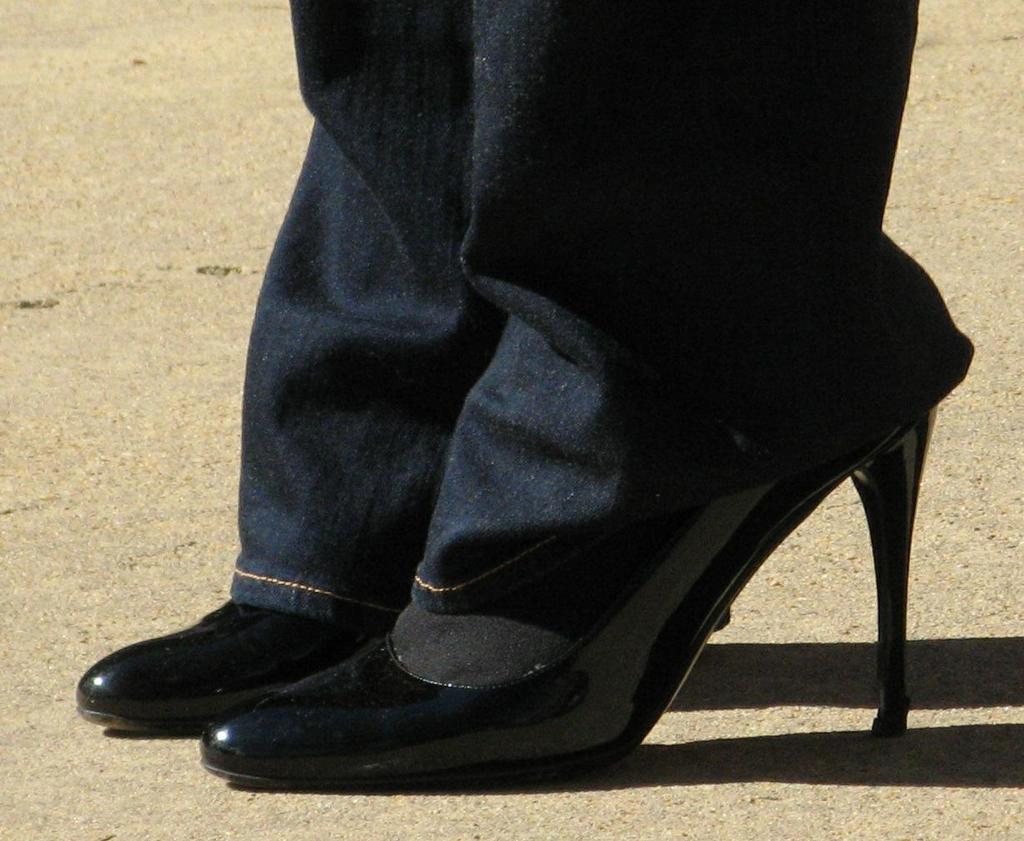Describe this image in one or two sentences. In this image I can see a person legs and a black color shoes. 